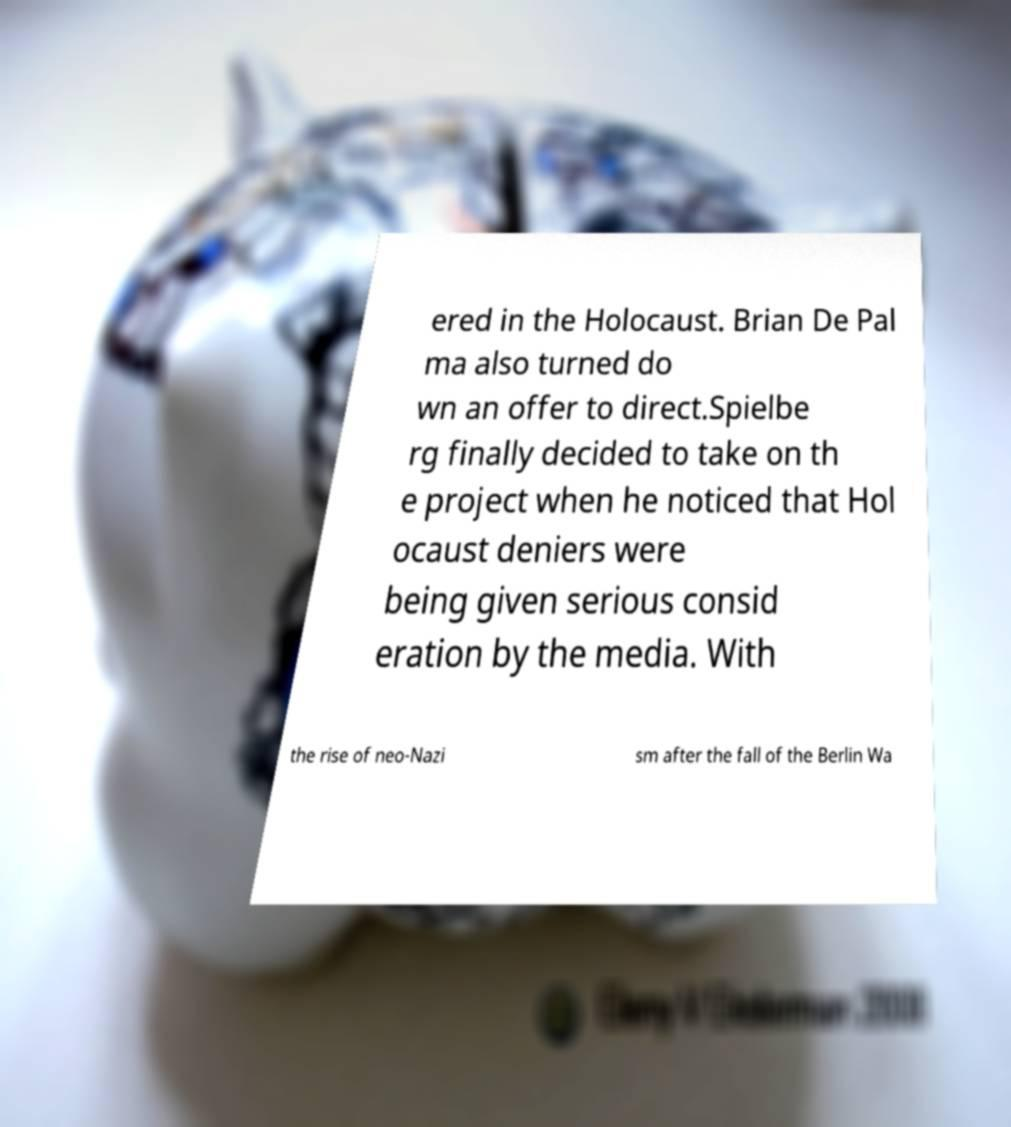Can you read and provide the text displayed in the image?This photo seems to have some interesting text. Can you extract and type it out for me? ered in the Holocaust. Brian De Pal ma also turned do wn an offer to direct.Spielbe rg finally decided to take on th e project when he noticed that Hol ocaust deniers were being given serious consid eration by the media. With the rise of neo-Nazi sm after the fall of the Berlin Wa 